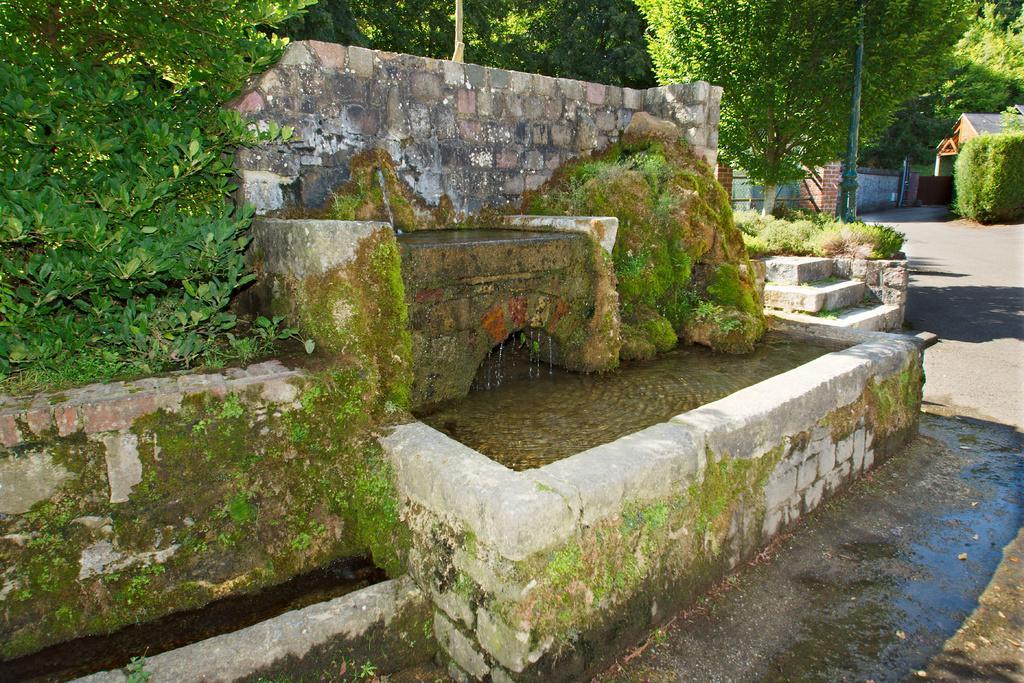Please provide a concise description of this image. In this image I can see water in the front and on the left side of it I can see a plant. In the background I can see number of trees, a building, a road, few plants, few poles and shadows on the ground. 